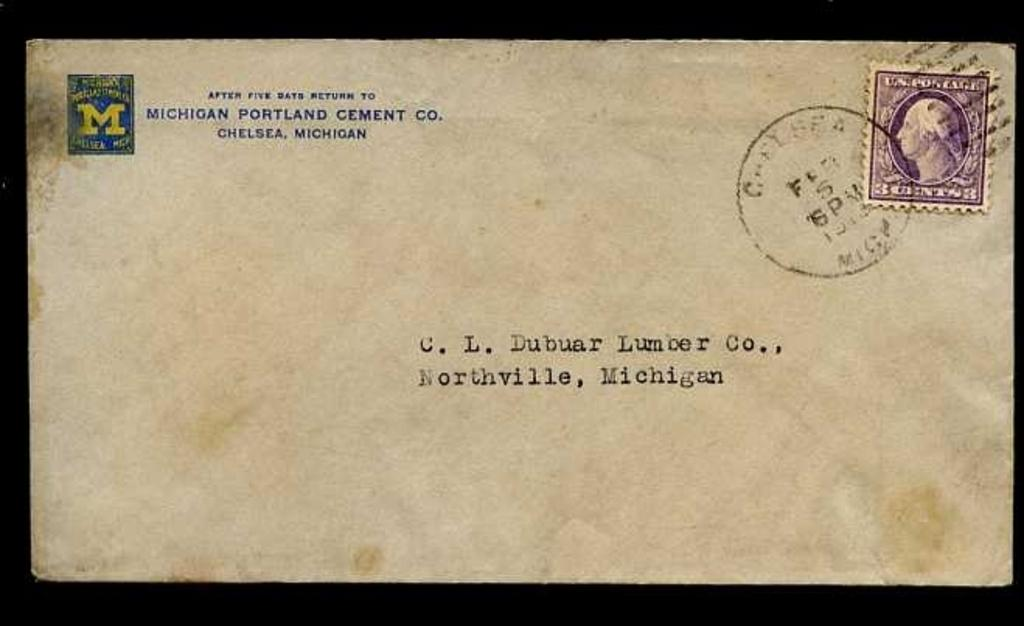Provide a one-sentence caption for the provided image. An old letter from Michigan Portland Cement Co. 